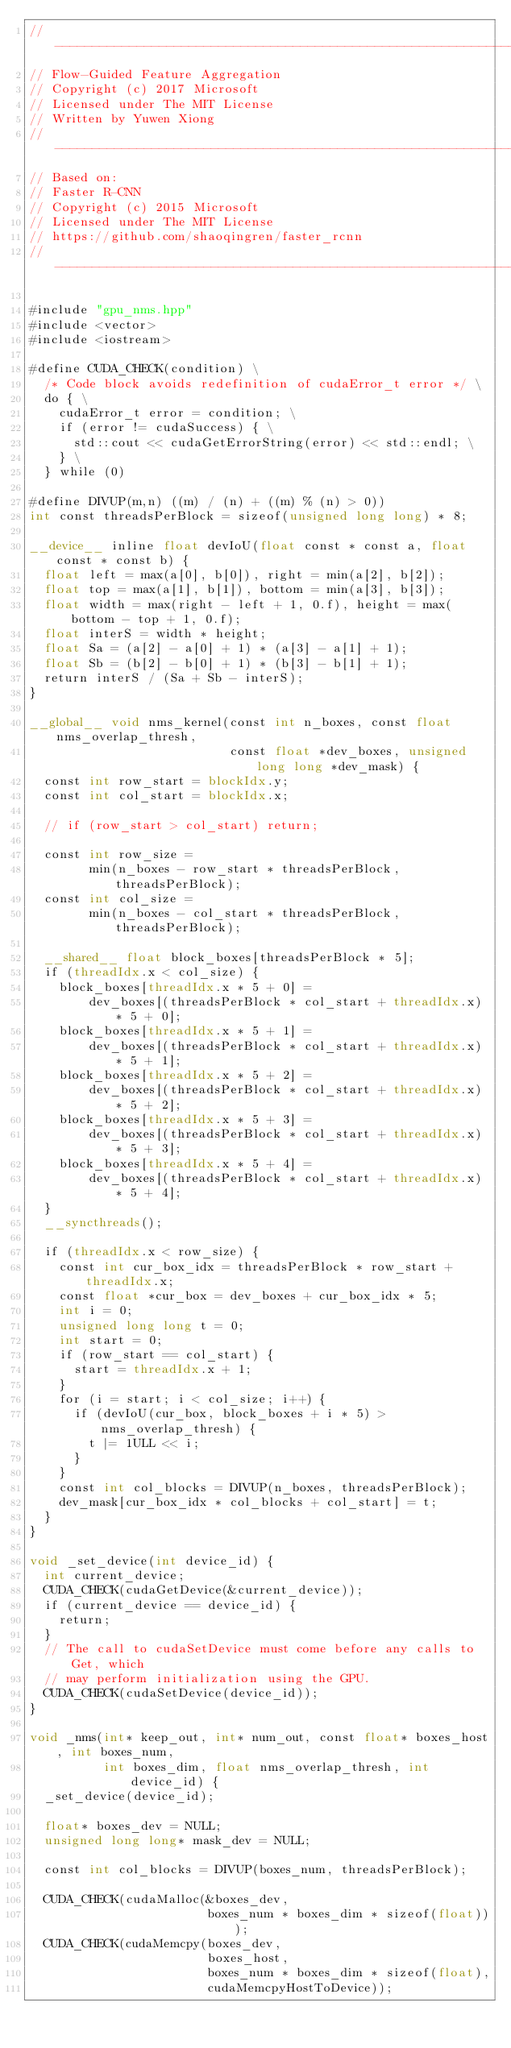Convert code to text. <code><loc_0><loc_0><loc_500><loc_500><_Cuda_>// ------------------------------------------------------------------
// Flow-Guided Feature Aggregation
// Copyright (c) 2017 Microsoft
// Licensed under The MIT License
// Written by Yuwen Xiong
// ------------------------------------------------------------------
// Based on:
// Faster R-CNN
// Copyright (c) 2015 Microsoft
// Licensed under The MIT License
// https://github.com/shaoqingren/faster_rcnn
// ------------------------------------------------------------------

#include "gpu_nms.hpp"
#include <vector>
#include <iostream>

#define CUDA_CHECK(condition) \
  /* Code block avoids redefinition of cudaError_t error */ \
  do { \
    cudaError_t error = condition; \
    if (error != cudaSuccess) { \
      std::cout << cudaGetErrorString(error) << std::endl; \
    } \
  } while (0)

#define DIVUP(m,n) ((m) / (n) + ((m) % (n) > 0))
int const threadsPerBlock = sizeof(unsigned long long) * 8;

__device__ inline float devIoU(float const * const a, float const * const b) {
  float left = max(a[0], b[0]), right = min(a[2], b[2]);
  float top = max(a[1], b[1]), bottom = min(a[3], b[3]);
  float width = max(right - left + 1, 0.f), height = max(bottom - top + 1, 0.f);
  float interS = width * height;
  float Sa = (a[2] - a[0] + 1) * (a[3] - a[1] + 1);
  float Sb = (b[2] - b[0] + 1) * (b[3] - b[1] + 1);
  return interS / (Sa + Sb - interS);
}

__global__ void nms_kernel(const int n_boxes, const float nms_overlap_thresh,
                           const float *dev_boxes, unsigned long long *dev_mask) {
  const int row_start = blockIdx.y;
  const int col_start = blockIdx.x;

  // if (row_start > col_start) return;

  const int row_size =
        min(n_boxes - row_start * threadsPerBlock, threadsPerBlock);
  const int col_size =
        min(n_boxes - col_start * threadsPerBlock, threadsPerBlock);

  __shared__ float block_boxes[threadsPerBlock * 5];
  if (threadIdx.x < col_size) {
    block_boxes[threadIdx.x * 5 + 0] =
        dev_boxes[(threadsPerBlock * col_start + threadIdx.x) * 5 + 0];
    block_boxes[threadIdx.x * 5 + 1] =
        dev_boxes[(threadsPerBlock * col_start + threadIdx.x) * 5 + 1];
    block_boxes[threadIdx.x * 5 + 2] =
        dev_boxes[(threadsPerBlock * col_start + threadIdx.x) * 5 + 2];
    block_boxes[threadIdx.x * 5 + 3] =
        dev_boxes[(threadsPerBlock * col_start + threadIdx.x) * 5 + 3];
    block_boxes[threadIdx.x * 5 + 4] =
        dev_boxes[(threadsPerBlock * col_start + threadIdx.x) * 5 + 4];
  }
  __syncthreads();

  if (threadIdx.x < row_size) {
    const int cur_box_idx = threadsPerBlock * row_start + threadIdx.x;
    const float *cur_box = dev_boxes + cur_box_idx * 5;
    int i = 0;
    unsigned long long t = 0;
    int start = 0;
    if (row_start == col_start) {
      start = threadIdx.x + 1;
    }
    for (i = start; i < col_size; i++) {
      if (devIoU(cur_box, block_boxes + i * 5) > nms_overlap_thresh) {
        t |= 1ULL << i;
      }
    }
    const int col_blocks = DIVUP(n_boxes, threadsPerBlock);
    dev_mask[cur_box_idx * col_blocks + col_start] = t;
  }
}

void _set_device(int device_id) {
  int current_device;
  CUDA_CHECK(cudaGetDevice(&current_device));
  if (current_device == device_id) {
    return;
  }
  // The call to cudaSetDevice must come before any calls to Get, which
  // may perform initialization using the GPU.
  CUDA_CHECK(cudaSetDevice(device_id));
}

void _nms(int* keep_out, int* num_out, const float* boxes_host, int boxes_num,
          int boxes_dim, float nms_overlap_thresh, int device_id) {
  _set_device(device_id);

  float* boxes_dev = NULL;
  unsigned long long* mask_dev = NULL;

  const int col_blocks = DIVUP(boxes_num, threadsPerBlock);

  CUDA_CHECK(cudaMalloc(&boxes_dev,
                        boxes_num * boxes_dim * sizeof(float)));
  CUDA_CHECK(cudaMemcpy(boxes_dev,
                        boxes_host,
                        boxes_num * boxes_dim * sizeof(float),
                        cudaMemcpyHostToDevice));
</code> 